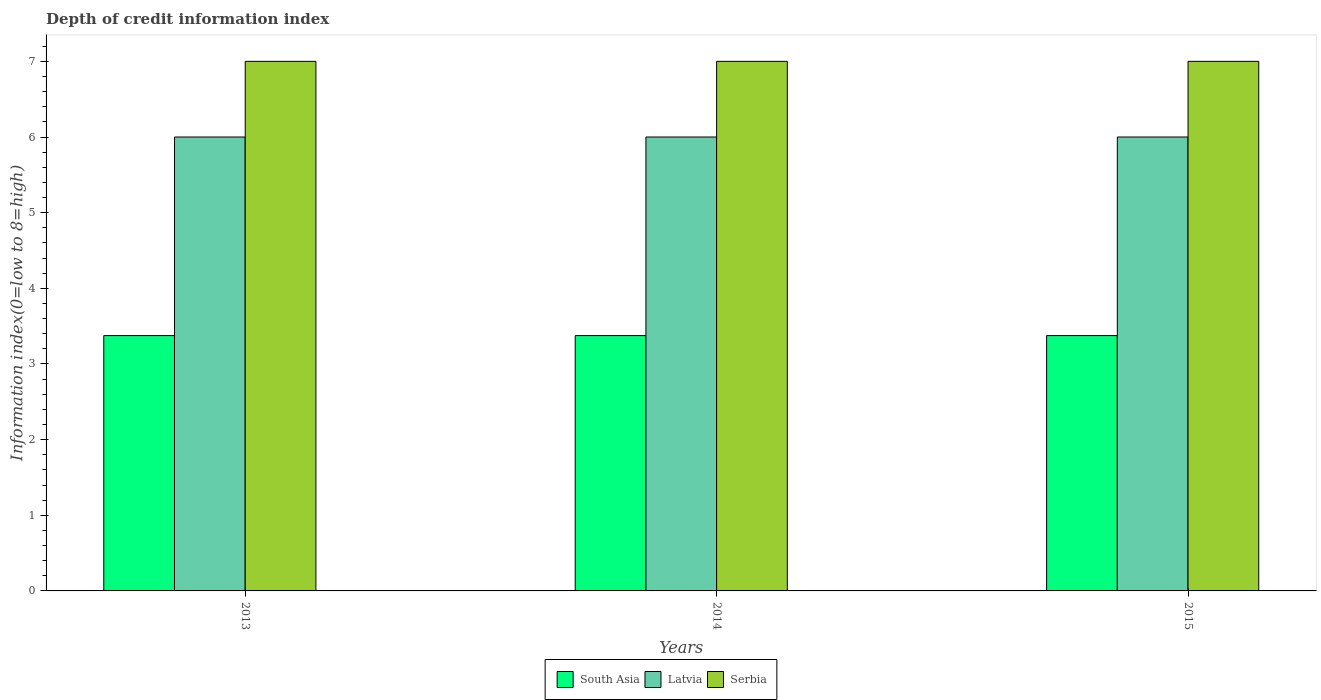Are the number of bars per tick equal to the number of legend labels?
Your answer should be compact. Yes. Are the number of bars on each tick of the X-axis equal?
Keep it short and to the point. Yes. How many bars are there on the 2nd tick from the left?
Offer a very short reply. 3. What is the label of the 2nd group of bars from the left?
Provide a short and direct response. 2014. In how many cases, is the number of bars for a given year not equal to the number of legend labels?
Ensure brevity in your answer.  0. Across all years, what is the maximum information index in Serbia?
Your answer should be compact. 7. Across all years, what is the minimum information index in South Asia?
Provide a short and direct response. 3.38. In which year was the information index in South Asia maximum?
Give a very brief answer. 2013. What is the total information index in Latvia in the graph?
Provide a succinct answer. 18. What is the difference between the information index in Serbia in 2015 and the information index in Latvia in 2013?
Offer a terse response. 1. What is the average information index in South Asia per year?
Offer a terse response. 3.38. In the year 2015, what is the difference between the information index in Serbia and information index in Latvia?
Your answer should be compact. 1. Is the information index in South Asia in 2013 less than that in 2015?
Your response must be concise. No. What is the difference between the highest and the lowest information index in Serbia?
Your answer should be compact. 0. Is the sum of the information index in South Asia in 2013 and 2014 greater than the maximum information index in Latvia across all years?
Provide a succinct answer. Yes. What does the 2nd bar from the left in 2013 represents?
Provide a succinct answer. Latvia. What does the 2nd bar from the right in 2015 represents?
Ensure brevity in your answer.  Latvia. Is it the case that in every year, the sum of the information index in South Asia and information index in Latvia is greater than the information index in Serbia?
Your answer should be compact. Yes. What is the difference between two consecutive major ticks on the Y-axis?
Your answer should be very brief. 1. Does the graph contain grids?
Provide a short and direct response. No. What is the title of the graph?
Your answer should be compact. Depth of credit information index. Does "Portugal" appear as one of the legend labels in the graph?
Your response must be concise. No. What is the label or title of the Y-axis?
Keep it short and to the point. Information index(0=low to 8=high). What is the Information index(0=low to 8=high) of South Asia in 2013?
Keep it short and to the point. 3.38. What is the Information index(0=low to 8=high) of Latvia in 2013?
Offer a very short reply. 6. What is the Information index(0=low to 8=high) in Serbia in 2013?
Offer a terse response. 7. What is the Information index(0=low to 8=high) of South Asia in 2014?
Provide a succinct answer. 3.38. What is the Information index(0=low to 8=high) of Serbia in 2014?
Ensure brevity in your answer.  7. What is the Information index(0=low to 8=high) in South Asia in 2015?
Provide a short and direct response. 3.38. Across all years, what is the maximum Information index(0=low to 8=high) of South Asia?
Your response must be concise. 3.38. Across all years, what is the maximum Information index(0=low to 8=high) in Latvia?
Make the answer very short. 6. Across all years, what is the maximum Information index(0=low to 8=high) in Serbia?
Make the answer very short. 7. Across all years, what is the minimum Information index(0=low to 8=high) of South Asia?
Keep it short and to the point. 3.38. Across all years, what is the minimum Information index(0=low to 8=high) in Latvia?
Your answer should be compact. 6. Across all years, what is the minimum Information index(0=low to 8=high) in Serbia?
Your response must be concise. 7. What is the total Information index(0=low to 8=high) of South Asia in the graph?
Provide a succinct answer. 10.12. What is the difference between the Information index(0=low to 8=high) in South Asia in 2013 and that in 2014?
Keep it short and to the point. 0. What is the difference between the Information index(0=low to 8=high) in Latvia in 2013 and that in 2015?
Provide a short and direct response. 0. What is the difference between the Information index(0=low to 8=high) of South Asia in 2014 and that in 2015?
Your answer should be very brief. 0. What is the difference between the Information index(0=low to 8=high) of Latvia in 2014 and that in 2015?
Your response must be concise. 0. What is the difference between the Information index(0=low to 8=high) in South Asia in 2013 and the Information index(0=low to 8=high) in Latvia in 2014?
Your response must be concise. -2.62. What is the difference between the Information index(0=low to 8=high) in South Asia in 2013 and the Information index(0=low to 8=high) in Serbia in 2014?
Your answer should be very brief. -3.62. What is the difference between the Information index(0=low to 8=high) in South Asia in 2013 and the Information index(0=low to 8=high) in Latvia in 2015?
Provide a succinct answer. -2.62. What is the difference between the Information index(0=low to 8=high) in South Asia in 2013 and the Information index(0=low to 8=high) in Serbia in 2015?
Ensure brevity in your answer.  -3.62. What is the difference between the Information index(0=low to 8=high) of South Asia in 2014 and the Information index(0=low to 8=high) of Latvia in 2015?
Give a very brief answer. -2.62. What is the difference between the Information index(0=low to 8=high) of South Asia in 2014 and the Information index(0=low to 8=high) of Serbia in 2015?
Offer a very short reply. -3.62. What is the difference between the Information index(0=low to 8=high) in Latvia in 2014 and the Information index(0=low to 8=high) in Serbia in 2015?
Ensure brevity in your answer.  -1. What is the average Information index(0=low to 8=high) of South Asia per year?
Your answer should be compact. 3.38. What is the average Information index(0=low to 8=high) in Serbia per year?
Make the answer very short. 7. In the year 2013, what is the difference between the Information index(0=low to 8=high) of South Asia and Information index(0=low to 8=high) of Latvia?
Provide a succinct answer. -2.62. In the year 2013, what is the difference between the Information index(0=low to 8=high) of South Asia and Information index(0=low to 8=high) of Serbia?
Give a very brief answer. -3.62. In the year 2014, what is the difference between the Information index(0=low to 8=high) in South Asia and Information index(0=low to 8=high) in Latvia?
Your answer should be very brief. -2.62. In the year 2014, what is the difference between the Information index(0=low to 8=high) in South Asia and Information index(0=low to 8=high) in Serbia?
Offer a very short reply. -3.62. In the year 2015, what is the difference between the Information index(0=low to 8=high) in South Asia and Information index(0=low to 8=high) in Latvia?
Provide a succinct answer. -2.62. In the year 2015, what is the difference between the Information index(0=low to 8=high) of South Asia and Information index(0=low to 8=high) of Serbia?
Give a very brief answer. -3.62. What is the ratio of the Information index(0=low to 8=high) in South Asia in 2013 to that in 2014?
Your response must be concise. 1. What is the ratio of the Information index(0=low to 8=high) in Serbia in 2013 to that in 2014?
Make the answer very short. 1. What is the ratio of the Information index(0=low to 8=high) of South Asia in 2013 to that in 2015?
Keep it short and to the point. 1. What is the ratio of the Information index(0=low to 8=high) of Latvia in 2013 to that in 2015?
Your response must be concise. 1. What is the ratio of the Information index(0=low to 8=high) in Latvia in 2014 to that in 2015?
Ensure brevity in your answer.  1. What is the ratio of the Information index(0=low to 8=high) of Serbia in 2014 to that in 2015?
Make the answer very short. 1. What is the difference between the highest and the second highest Information index(0=low to 8=high) in South Asia?
Provide a short and direct response. 0. What is the difference between the highest and the second highest Information index(0=low to 8=high) in Latvia?
Give a very brief answer. 0. What is the difference between the highest and the lowest Information index(0=low to 8=high) of South Asia?
Your answer should be compact. 0. What is the difference between the highest and the lowest Information index(0=low to 8=high) in Serbia?
Your answer should be compact. 0. 